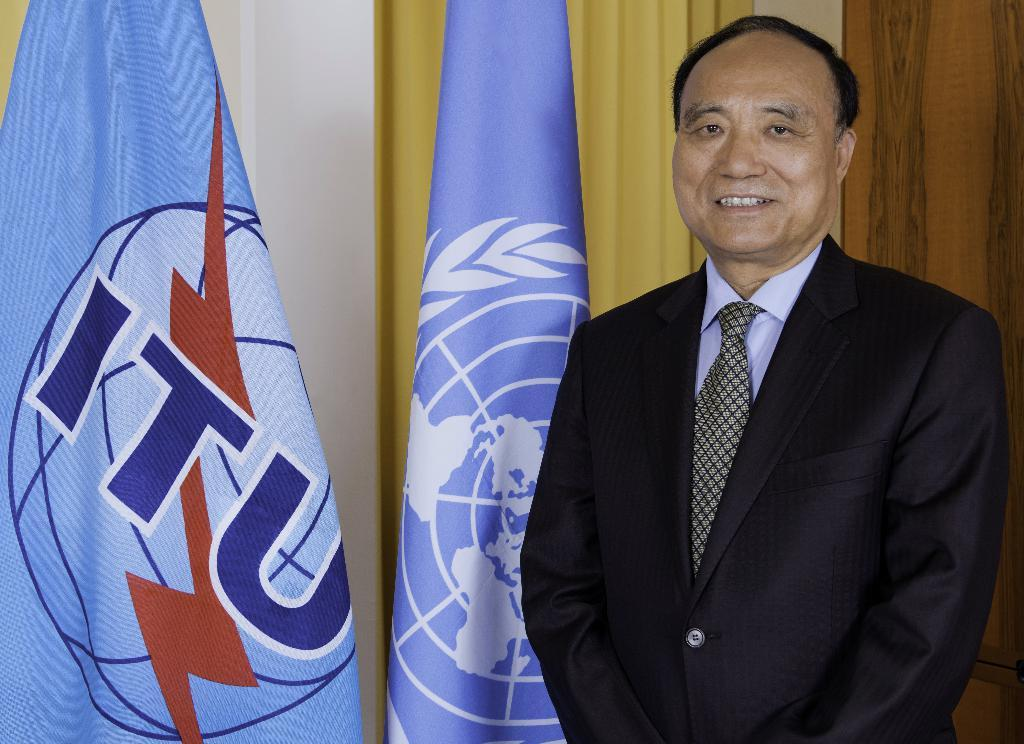Who is present in the image? There is a person in the image. What is the person's expression? The person is smiling. What can be seen near the person? There are flags near the person. What is visible in the background of the image? There is a wall in the background of the image. Is there any window treatment present in the image? Yes, there is a curtain associated with the wall. What type of whip is the person using in the image? There is no whip present in the image. What is the person eating for dinner in the image? The image does not show the person eating dinner, so it cannot be determined from the image. 